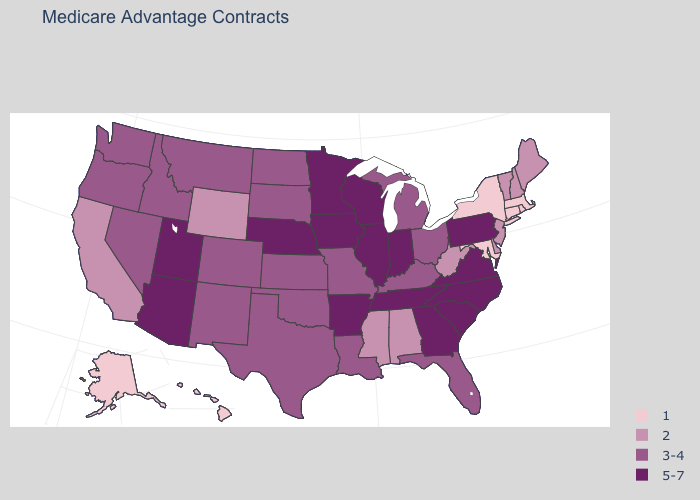Among the states that border Rhode Island , which have the highest value?
Keep it brief. Connecticut, Massachusetts. What is the value of Nebraska?
Be succinct. 5-7. Which states hav the highest value in the South?
Give a very brief answer. Arkansas, Georgia, North Carolina, South Carolina, Tennessee, Virginia. Name the states that have a value in the range 3-4?
Concise answer only. Colorado, Florida, Idaho, Kansas, Kentucky, Louisiana, Michigan, Missouri, Montana, North Dakota, New Mexico, Nevada, Ohio, Oklahoma, Oregon, South Dakota, Texas, Washington. Is the legend a continuous bar?
Write a very short answer. No. Does South Carolina have the highest value in the USA?
Answer briefly. Yes. Which states have the lowest value in the MidWest?
Concise answer only. Kansas, Michigan, Missouri, North Dakota, Ohio, South Dakota. What is the lowest value in the MidWest?
Short answer required. 3-4. What is the value of Louisiana?
Be succinct. 3-4. Does New York have the lowest value in the Northeast?
Short answer required. Yes. Which states hav the highest value in the Northeast?
Write a very short answer. Pennsylvania. Name the states that have a value in the range 1?
Write a very short answer. Alaska, Connecticut, Hawaii, Massachusetts, Maryland, New York, Rhode Island. What is the value of Iowa?
Write a very short answer. 5-7. Name the states that have a value in the range 1?
Quick response, please. Alaska, Connecticut, Hawaii, Massachusetts, Maryland, New York, Rhode Island. Name the states that have a value in the range 3-4?
Be succinct. Colorado, Florida, Idaho, Kansas, Kentucky, Louisiana, Michigan, Missouri, Montana, North Dakota, New Mexico, Nevada, Ohio, Oklahoma, Oregon, South Dakota, Texas, Washington. 